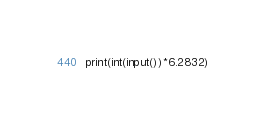Convert code to text. <code><loc_0><loc_0><loc_500><loc_500><_Python_>print(int(input())*6.2832)</code> 